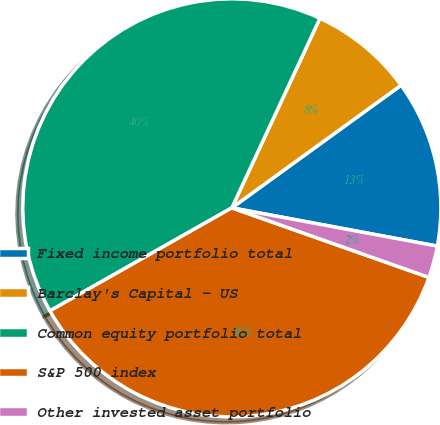Convert chart. <chart><loc_0><loc_0><loc_500><loc_500><pie_chart><fcel>Fixed income portfolio total<fcel>Barclay's Capital - US<fcel>Common equity portfolio total<fcel>S&P 500 index<fcel>Other invested asset portfolio<nl><fcel>12.91%<fcel>8.1%<fcel>40.12%<fcel>36.4%<fcel>2.47%<nl></chart> 